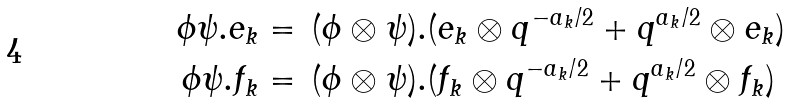Convert formula to latex. <formula><loc_0><loc_0><loc_500><loc_500>\phi \psi . e _ { k } & = \, ( \phi \otimes \psi ) . ( e _ { k } \otimes q ^ { - a _ { k } / 2 } + q ^ { a _ { k } / 2 } \otimes e _ { k } ) \\ \phi \psi . f _ { k } & = \, ( \phi \otimes \psi ) . ( f _ { k } \otimes q ^ { - a _ { k } / 2 } + q ^ { a _ { k } / 2 } \otimes f _ { k } )</formula> 